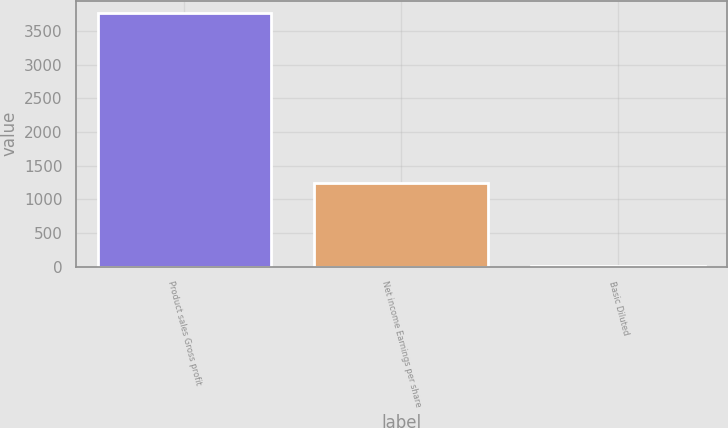Convert chart to OTSL. <chart><loc_0><loc_0><loc_500><loc_500><bar_chart><fcel>Product sales Gross profit<fcel>Net income Earnings per share<fcel>Basic Diluted<nl><fcel>3759<fcel>1236<fcel>1.28<nl></chart> 